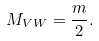Convert formula to latex. <formula><loc_0><loc_0><loc_500><loc_500>M _ { V W } = \frac { m } { 2 } .</formula> 